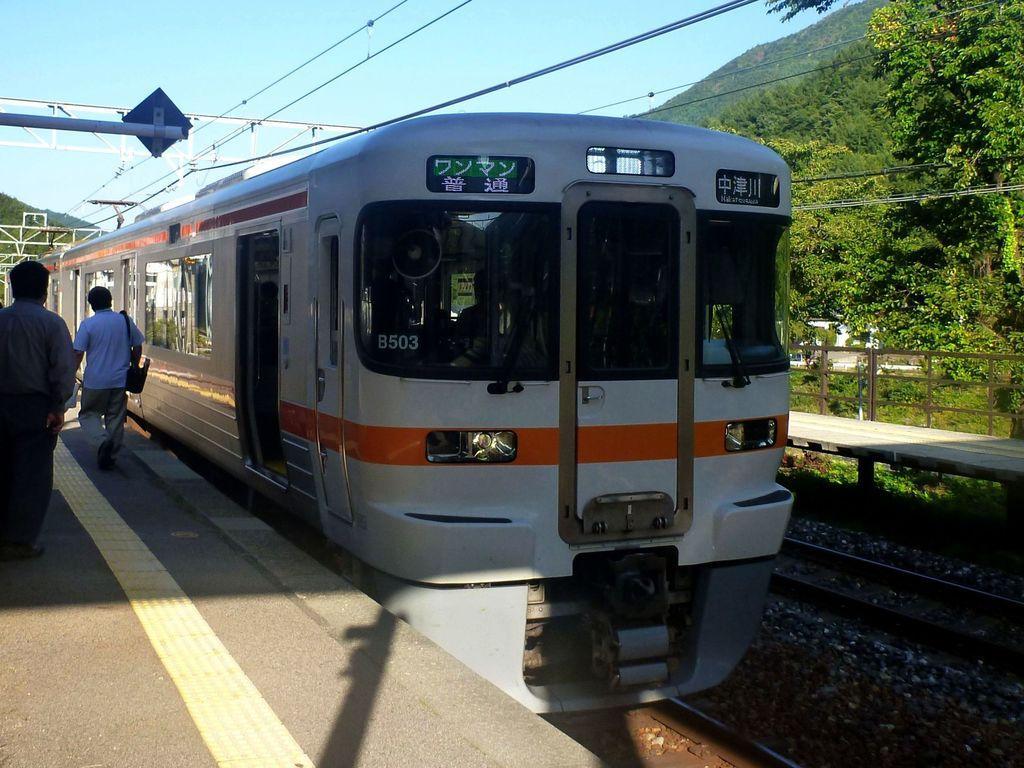Describe this image in one or two sentences. In this image I can see a train. There are railway tracks, two persons on the platform, trees, pebbles, hills, cables, iron strings and in the background there is sky. 